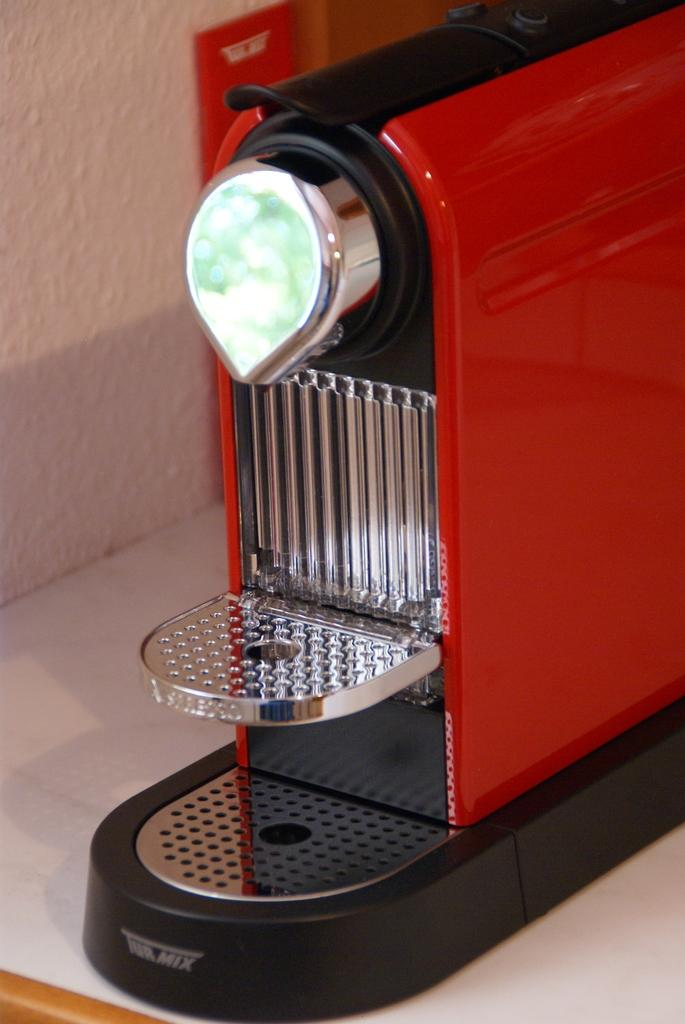What is the main object in the image? There is a vegetable cutting machine in the image. What is the color of the surface the vegetable cutting machine is on? The vegetable cutting machine is on a white surface. What can be seen in the background of the image? There is a wall visible in the image. How many pears are on the vegetable cutting machine in the image? There are no pears present in the image; the vegetable cutting machine is the main object. 